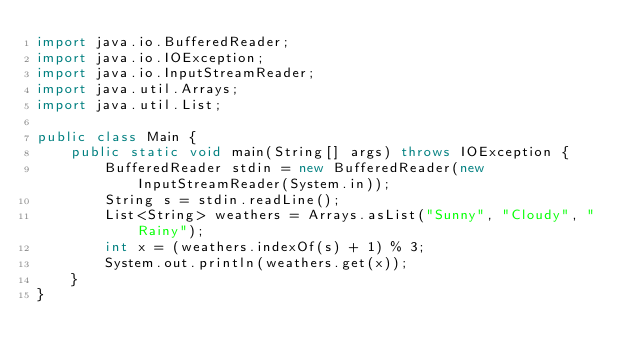<code> <loc_0><loc_0><loc_500><loc_500><_Java_>import java.io.BufferedReader;
import java.io.IOException;
import java.io.InputStreamReader;
import java.util.Arrays;
import java.util.List;

public class Main {
    public static void main(String[] args) throws IOException {
        BufferedReader stdin = new BufferedReader(new InputStreamReader(System.in));
        String s = stdin.readLine();
        List<String> weathers = Arrays.asList("Sunny", "Cloudy", "Rainy");
        int x = (weathers.indexOf(s) + 1) % 3;
        System.out.println(weathers.get(x));
    }
}
</code> 